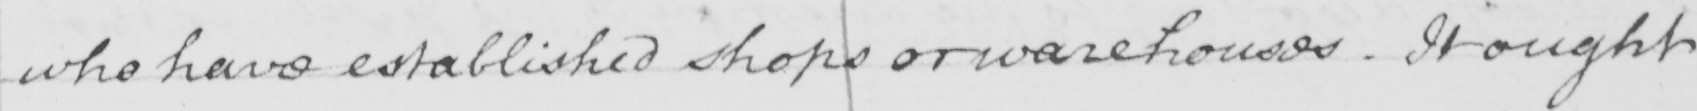What is written in this line of handwriting? who have established shops or warehouses . It ought 